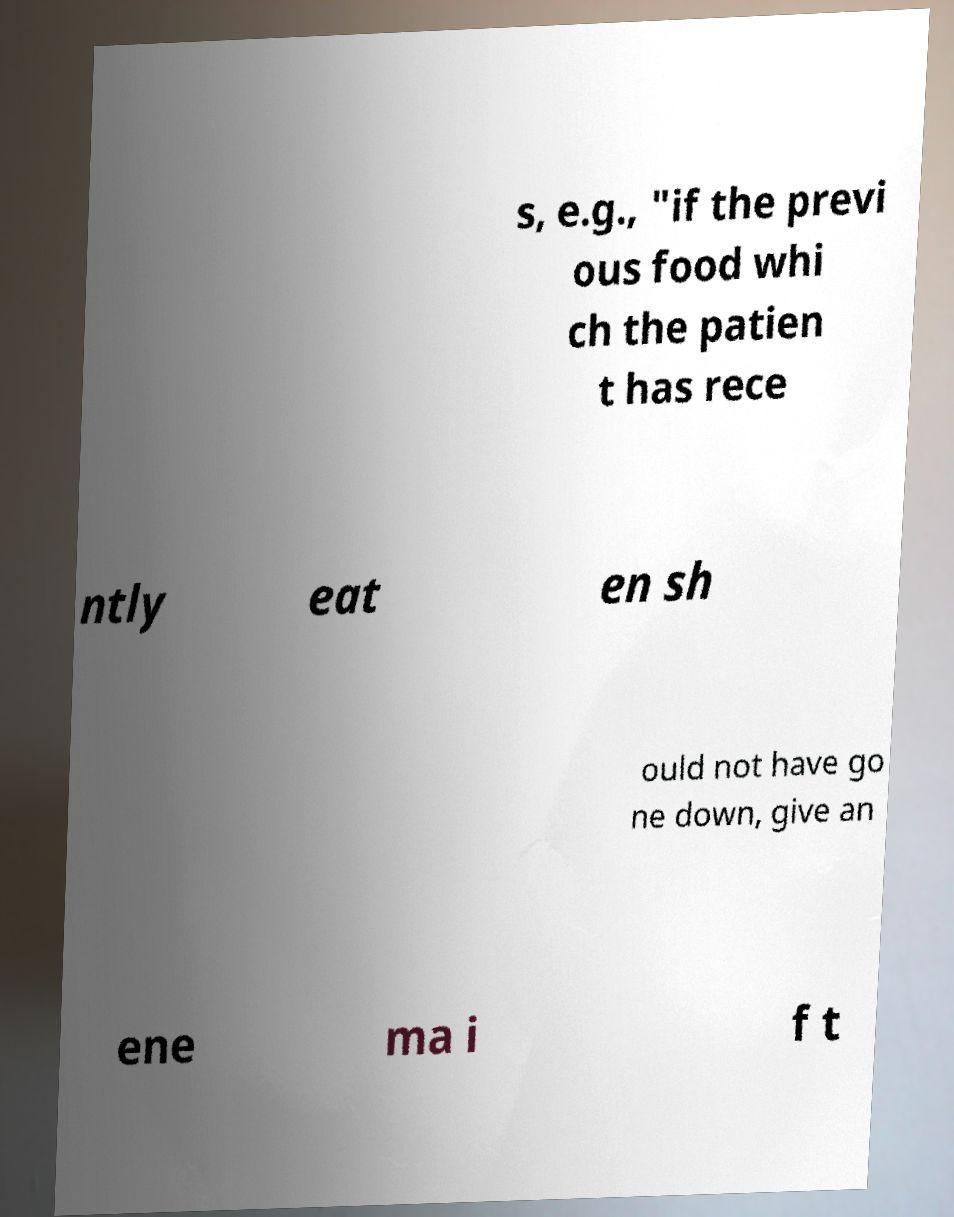Can you read and provide the text displayed in the image?This photo seems to have some interesting text. Can you extract and type it out for me? s, e.g., "if the previ ous food whi ch the patien t has rece ntly eat en sh ould not have go ne down, give an ene ma i f t 